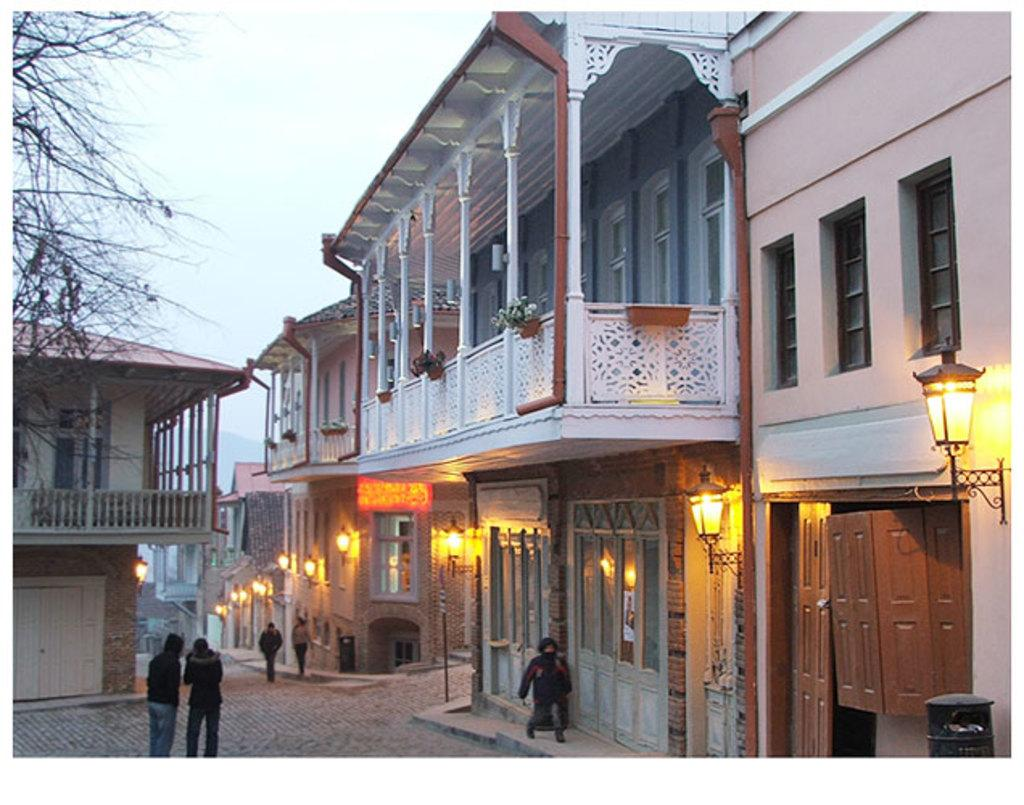What is located in the middle of the image? There are persons in the middle of the image. What type of structures can be seen in the image? There are buildings in the image. What can be seen on either side of the image? There are lights on either side of the image. What type of vegetation is on the left side of the image? There are trees on the left side of the image. What is visible at the top of the image? The sky is visible at the top of the image. What type of vegetable is growing on the right side of the image? There is no vegetable present in the image; it features persons, buildings, lights, trees, and the sky. What color is the gold statue in the image? There is no gold statue present in the image. 